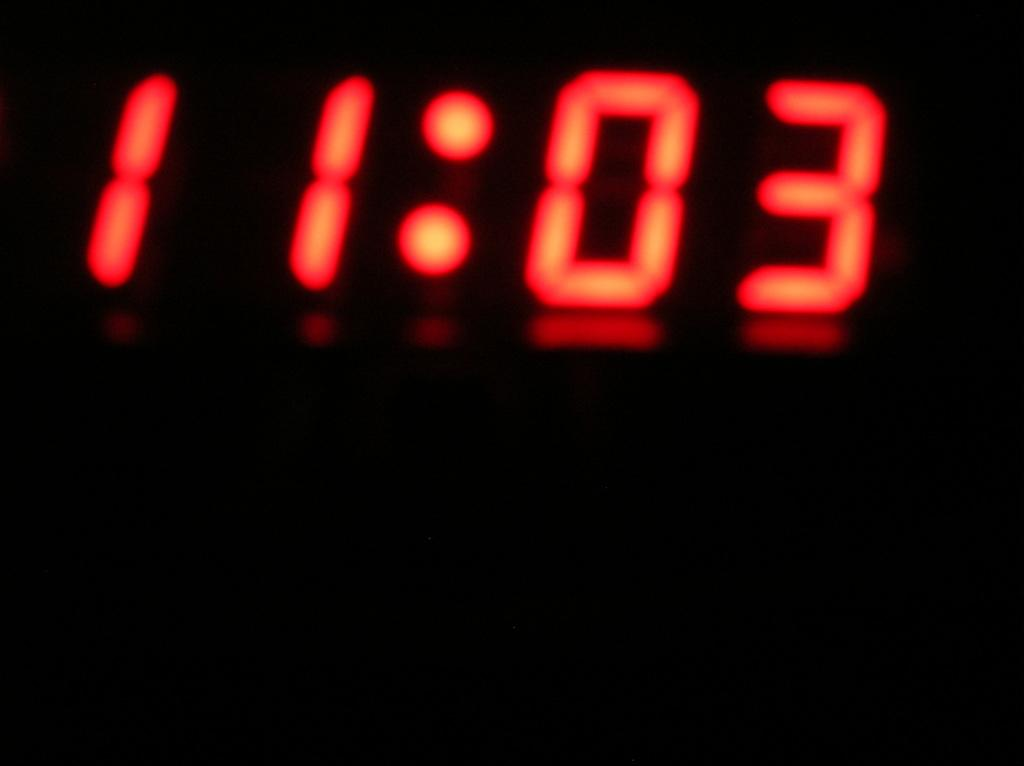<image>
Render a clear and concise summary of the photo. red and black clock with eleven o three on it 